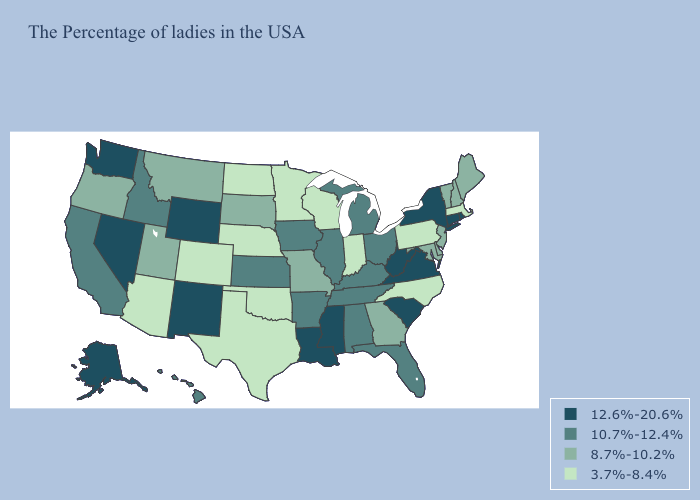What is the value of Alabama?
Quick response, please. 10.7%-12.4%. Which states have the lowest value in the South?
Answer briefly. North Carolina, Oklahoma, Texas. Does the map have missing data?
Quick response, please. No. Does West Virginia have the highest value in the South?
Answer briefly. Yes. Does the first symbol in the legend represent the smallest category?
Answer briefly. No. What is the highest value in states that border Iowa?
Quick response, please. 10.7%-12.4%. Does the first symbol in the legend represent the smallest category?
Quick response, please. No. Name the states that have a value in the range 8.7%-10.2%?
Give a very brief answer. Maine, New Hampshire, Vermont, New Jersey, Delaware, Maryland, Georgia, Missouri, South Dakota, Utah, Montana, Oregon. Name the states that have a value in the range 8.7%-10.2%?
Concise answer only. Maine, New Hampshire, Vermont, New Jersey, Delaware, Maryland, Georgia, Missouri, South Dakota, Utah, Montana, Oregon. Name the states that have a value in the range 8.7%-10.2%?
Give a very brief answer. Maine, New Hampshire, Vermont, New Jersey, Delaware, Maryland, Georgia, Missouri, South Dakota, Utah, Montana, Oregon. What is the highest value in the West ?
Answer briefly. 12.6%-20.6%. What is the value of Tennessee?
Write a very short answer. 10.7%-12.4%. What is the lowest value in states that border Arizona?
Answer briefly. 3.7%-8.4%. Does New Mexico have the highest value in the USA?
Be succinct. Yes. Does the first symbol in the legend represent the smallest category?
Keep it brief. No. 